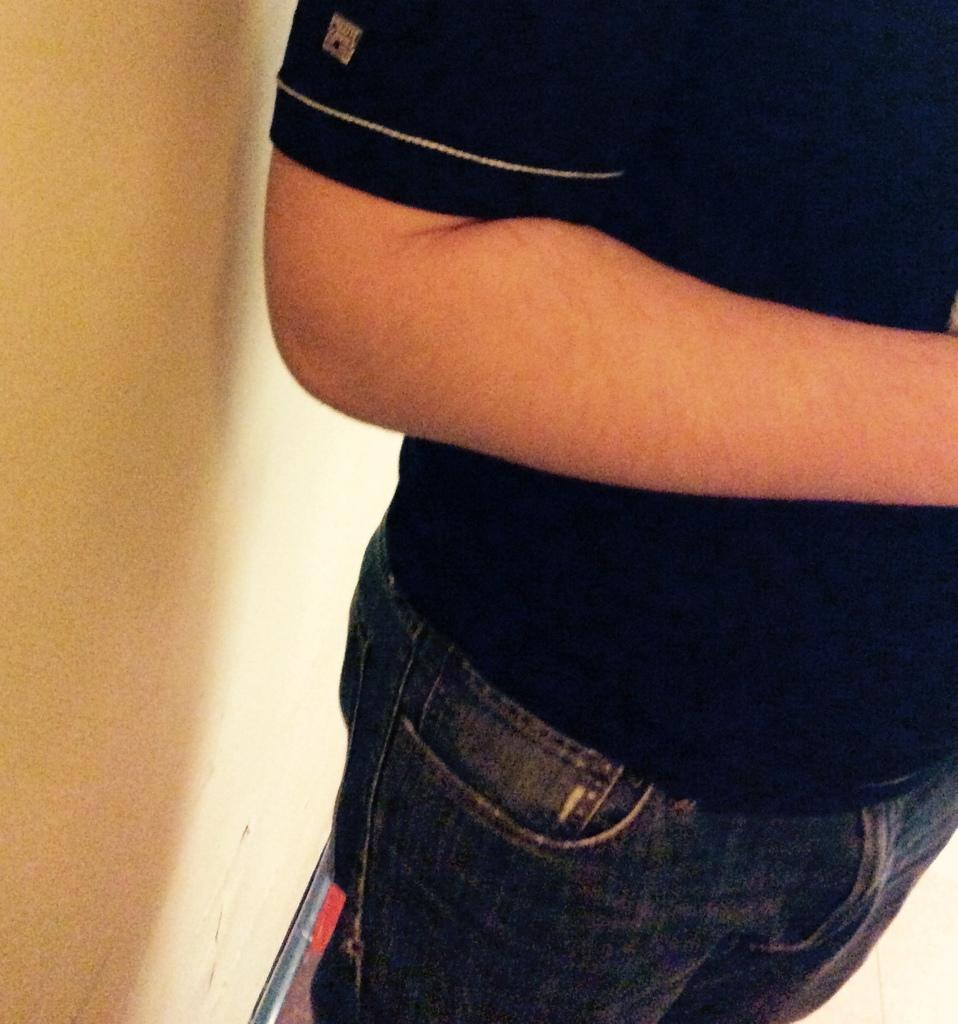What is the main subject of the image? There is a person standing in the image. What can be seen in the background of the image? There is a wall in the image. Are there any objects or structures visible in the image? Yes, there is a rod in the image. What type of fruit is hanging from the rod in the image? There is no fruit present in the image; only a person, a wall, and a rod are visible. 